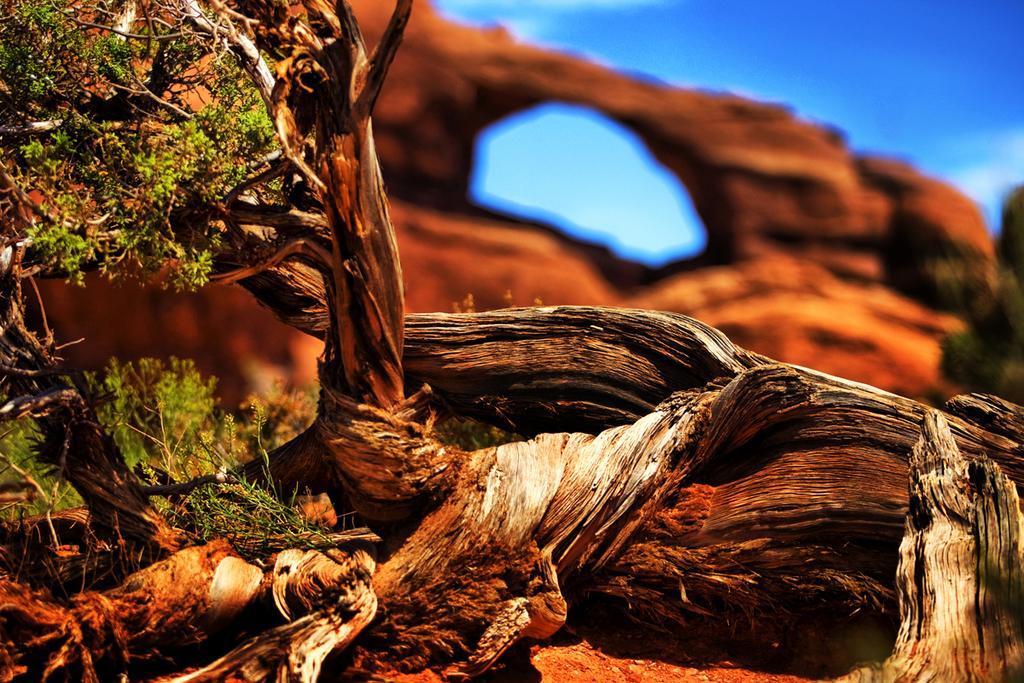Please provide a concise description of this image. In this image we can see one object looks like arches, one bite tree, some small plants on the ground, one object on the right side of the image and at the top there is the blue sky. 